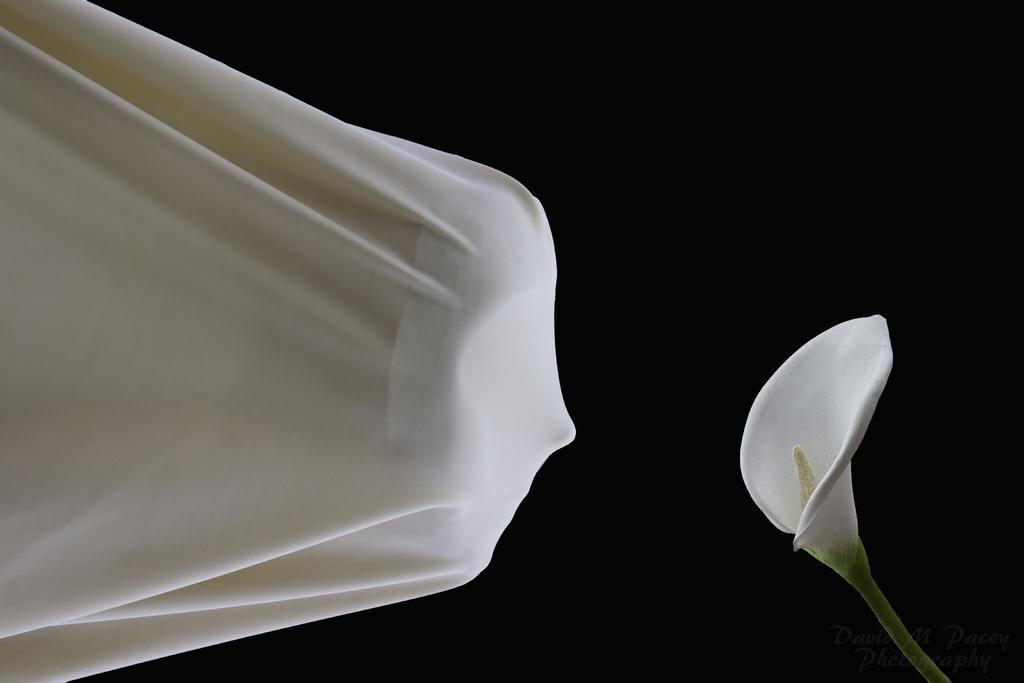In one or two sentences, can you explain what this image depicts? In the image I can see a cloth in which there is a mask and also I can see a flower in front of it. 